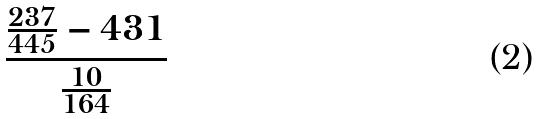Convert formula to latex. <formula><loc_0><loc_0><loc_500><loc_500>\frac { \frac { 2 3 7 } { 4 4 5 } - 4 3 1 } { \frac { 1 0 } { 1 6 4 } }</formula> 